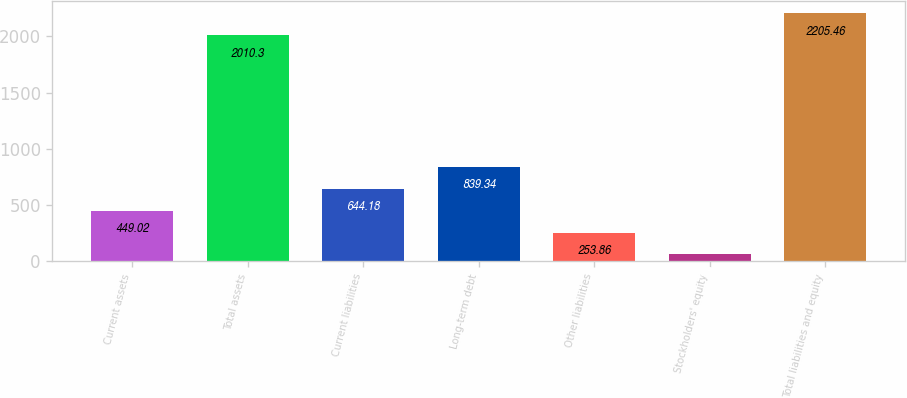Convert chart to OTSL. <chart><loc_0><loc_0><loc_500><loc_500><bar_chart><fcel>Current assets<fcel>Total assets<fcel>Current liabilities<fcel>Long-term debt<fcel>Other liabilities<fcel>Stockholders' equity<fcel>Total liabilities and equity<nl><fcel>449.02<fcel>2010.3<fcel>644.18<fcel>839.34<fcel>253.86<fcel>58.7<fcel>2205.46<nl></chart> 